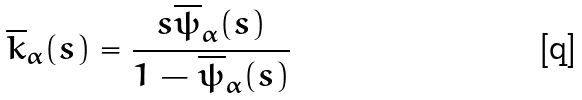Convert formula to latex. <formula><loc_0><loc_0><loc_500><loc_500>\overline { k } _ { \alpha } ( s ) = \frac { s \overline { \psi } _ { \alpha } ( s ) } { 1 - \overline { \psi } _ { \alpha } ( s ) }</formula> 